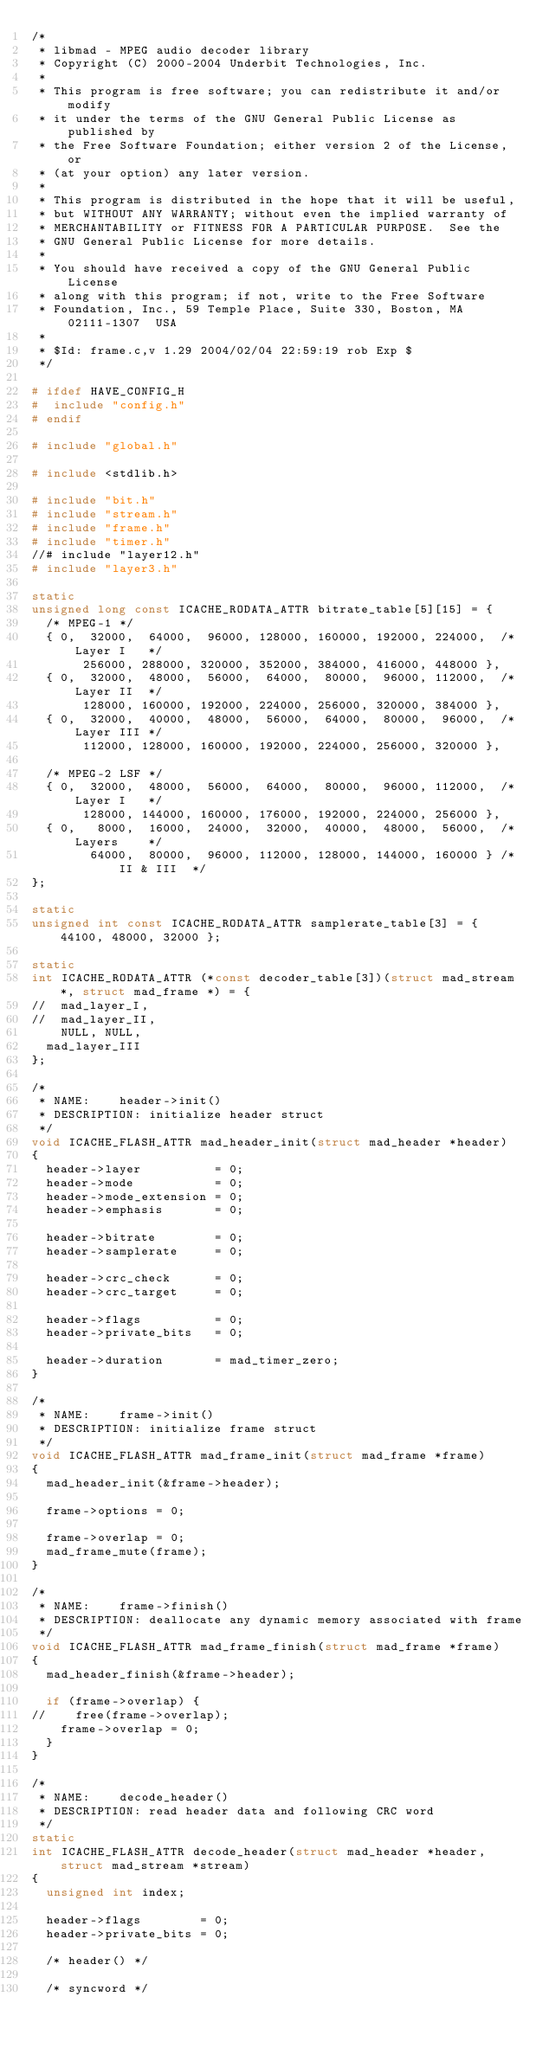<code> <loc_0><loc_0><loc_500><loc_500><_C_>/*
 * libmad - MPEG audio decoder library
 * Copyright (C) 2000-2004 Underbit Technologies, Inc.
 *
 * This program is free software; you can redistribute it and/or modify
 * it under the terms of the GNU General Public License as published by
 * the Free Software Foundation; either version 2 of the License, or
 * (at your option) any later version.
 *
 * This program is distributed in the hope that it will be useful,
 * but WITHOUT ANY WARRANTY; without even the implied warranty of
 * MERCHANTABILITY or FITNESS FOR A PARTICULAR PURPOSE.  See the
 * GNU General Public License for more details.
 *
 * You should have received a copy of the GNU General Public License
 * along with this program; if not, write to the Free Software
 * Foundation, Inc., 59 Temple Place, Suite 330, Boston, MA  02111-1307  USA
 *
 * $Id: frame.c,v 1.29 2004/02/04 22:59:19 rob Exp $
 */

# ifdef HAVE_CONFIG_H
#  include "config.h"
# endif

# include "global.h"

# include <stdlib.h>

# include "bit.h"
# include "stream.h"
# include "frame.h"
# include "timer.h"
//# include "layer12.h"
# include "layer3.h"

static
unsigned long const ICACHE_RODATA_ATTR bitrate_table[5][15] = {
  /* MPEG-1 */
  { 0,  32000,  64000,  96000, 128000, 160000, 192000, 224000,  /* Layer I   */
       256000, 288000, 320000, 352000, 384000, 416000, 448000 },
  { 0,  32000,  48000,  56000,  64000,  80000,  96000, 112000,  /* Layer II  */
       128000, 160000, 192000, 224000, 256000, 320000, 384000 },
  { 0,  32000,  40000,  48000,  56000,  64000,  80000,  96000,  /* Layer III */
       112000, 128000, 160000, 192000, 224000, 256000, 320000 },

  /* MPEG-2 LSF */
  { 0,  32000,  48000,  56000,  64000,  80000,  96000, 112000,  /* Layer I   */
       128000, 144000, 160000, 176000, 192000, 224000, 256000 },
  { 0,   8000,  16000,  24000,  32000,  40000,  48000,  56000,  /* Layers    */
        64000,  80000,  96000, 112000, 128000, 144000, 160000 } /* II & III  */
};

static
unsigned int const ICACHE_RODATA_ATTR samplerate_table[3] = { 44100, 48000, 32000 };

static
int ICACHE_RODATA_ATTR (*const decoder_table[3])(struct mad_stream *, struct mad_frame *) = {
//  mad_layer_I,
//  mad_layer_II,
	NULL, NULL,
  mad_layer_III
};

/*
 * NAME:	header->init()
 * DESCRIPTION:	initialize header struct
 */
void ICACHE_FLASH_ATTR mad_header_init(struct mad_header *header)
{
  header->layer          = 0;
  header->mode           = 0;
  header->mode_extension = 0;
  header->emphasis       = 0;

  header->bitrate        = 0;
  header->samplerate     = 0;

  header->crc_check      = 0;
  header->crc_target     = 0;

  header->flags          = 0;
  header->private_bits   = 0;

  header->duration       = mad_timer_zero;
}

/*
 * NAME:	frame->init()
 * DESCRIPTION:	initialize frame struct
 */
void ICACHE_FLASH_ATTR mad_frame_init(struct mad_frame *frame)
{
  mad_header_init(&frame->header);

  frame->options = 0;

  frame->overlap = 0;
  mad_frame_mute(frame);
}

/*
 * NAME:	frame->finish()
 * DESCRIPTION:	deallocate any dynamic memory associated with frame
 */
void ICACHE_FLASH_ATTR mad_frame_finish(struct mad_frame *frame)
{
  mad_header_finish(&frame->header);

  if (frame->overlap) {
//    free(frame->overlap);
    frame->overlap = 0;
  }
}

/*
 * NAME:	decode_header()
 * DESCRIPTION:	read header data and following CRC word
 */
static
int ICACHE_FLASH_ATTR decode_header(struct mad_header *header, struct mad_stream *stream)
{
  unsigned int index;

  header->flags        = 0;
  header->private_bits = 0;

  /* header() */

  /* syncword */</code> 